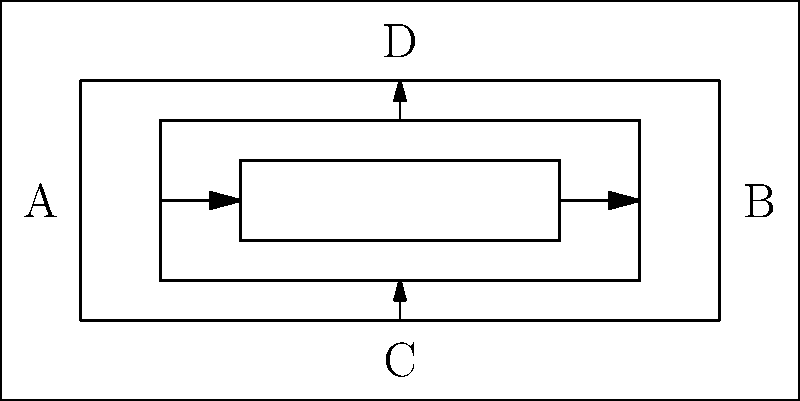In the Wydad AC stadium, the seating arrangement is divided into three concentric sections. Fans can move between adjacent sections through designated pathways. If a fan wants to move from point A to point B, what is the minimum number of section boundaries they must cross? To solve this problem, we need to analyze the connectivity of the seating sections and find the shortest path from point A to point B. Let's break it down step-by-step:

1. The stadium has three concentric sections, labeled from outermost to innermost.
2. Fans can move between adjacent sections through designated pathways.
3. Point A is located on the leftmost side of the outermost section.
4. Point B is located on the rightmost side of the outermost section.

To find the minimum number of section boundaries crossed:

1. Start at point A in the outermost section.
2. Move inward, crossing the first section boundary (1 crossing).
3. Move to the middle section.
4. Cross to the innermost section (2nd crossing).
5. Move across the innermost section.
6. Cross back to the middle section (3rd crossing).
7. Move to the right side of the middle section.
8. Cross to the outermost section (4th crossing).
9. Arrive at point B.

This path crosses 4 section boundaries, which is the minimum possible. Any other path would require crossing more boundaries or backtracking.
Answer: 4 